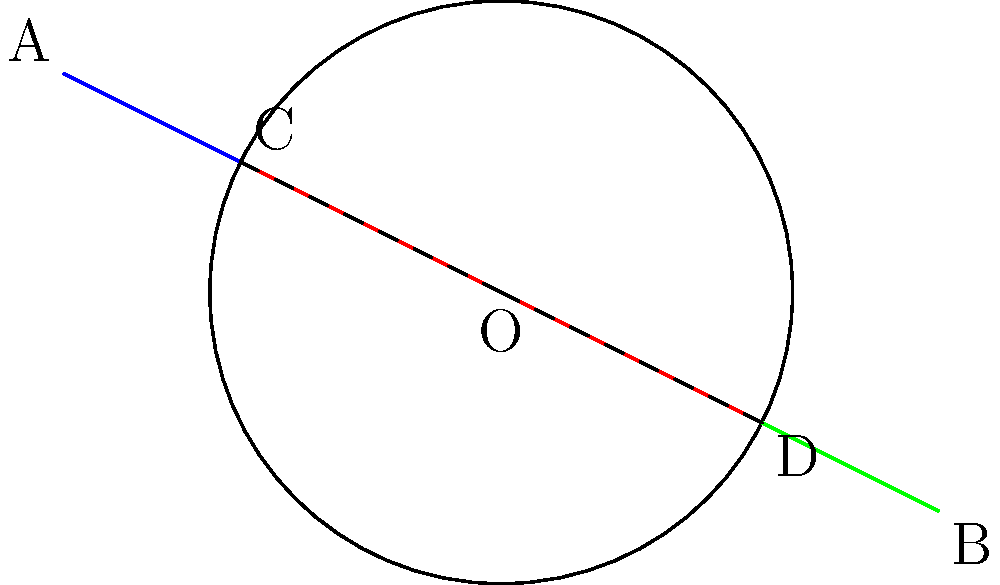In your latest fantasy novel, you've created a magical crystal ball that refracts light in peculiar ways. To ensure scientific accuracy, you decide to study the principles of refraction. In the diagram, a light ray enters a crystal ball at point C and exits at point D. If the angle of incidence at C is $30.0°$ and the refractive index of the crystal is $1.5$, what is the angle of refraction inside the crystal ball? Let's approach this step-by-step:

1) First, recall Snell's law: $n_1 \sin \theta_1 = n_2 \sin \theta_2$, where $n_1$ and $n_2$ are the refractive indices of the two media, and $\theta_1$ and $\theta_2$ are the angles of incidence and refraction respectively.

2) We're given:
   - Angle of incidence ($\theta_1$) = $30.0°$
   - Refractive index of air ($n_1$) ≈ 1.0
   - Refractive index of crystal ($n_2$) = 1.5

3) Let's plug these into Snell's law:
   $1.0 \sin 30.0° = 1.5 \sin \theta_2$

4) Simplify:
   $0.5 = 1.5 \sin \theta_2$

5) Solve for $\theta_2$:
   $\sin \theta_2 = \frac{0.5}{1.5} = \frac{1}{3}$

6) Take the inverse sine (arcsin) of both sides:
   $\theta_2 = \arcsin(\frac{1}{3})$

7) Calculate:
   $\theta_2 \approx 19.5°$

Therefore, the angle of refraction inside the crystal ball is approximately $19.5°$.
Answer: $19.5°$ 